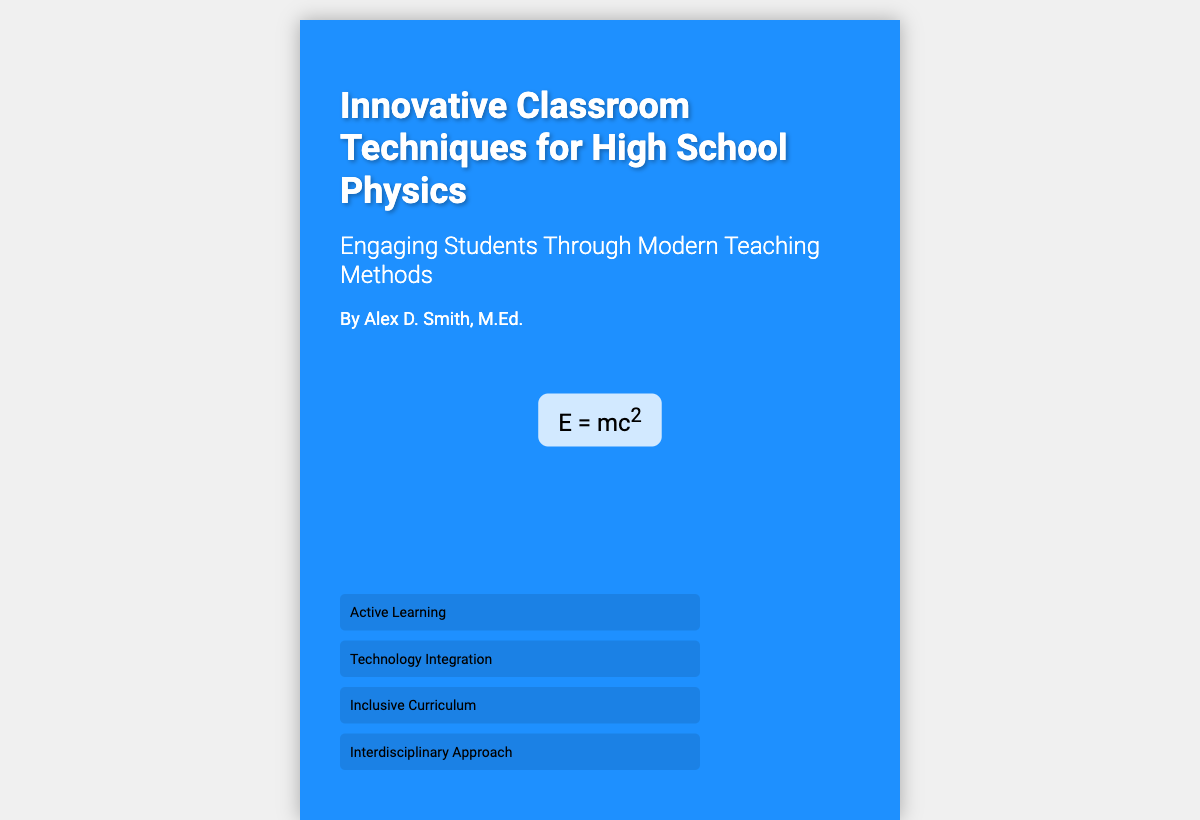What is the title of the book? The title of the book is prominently displayed on the cover, indicating the main subject of the document.
Answer: Innovative Classroom Techniques for High School Physics Who is the author of the book? The author's name is mentioned in the author section of the cover, providing credit to the writer.
Answer: Alex D. Smith, M.Ed What is the main theme of the book? The subtitle of the book gives insight into what the book aims to address regarding teaching methods.
Answer: Engaging Students Through Modern Teaching Methods How many key points are highlighted on the cover? The number of key points listed provides an overview of the main topics covered within the book.
Answer: Four What is one of the key points mentioned? The cover lists several key points to give a glimpse of the content; any one of them can be mentioned as an example.
Answer: Active Learning What visual element is included alongside the equation? The visual element gives a context of classroom activities, enhancing the design and educational theme of the cover.
Answer: Classroom activities What equation is featured on the cover? The equation displayed is a famous formula in physics, which signifies the scientific aspects discussed in the book.
Answer: E = mc² In what format is the cover designed? The type of design gives an idea about the modern approach to the presentation of the book.
Answer: Clean and modern layout 